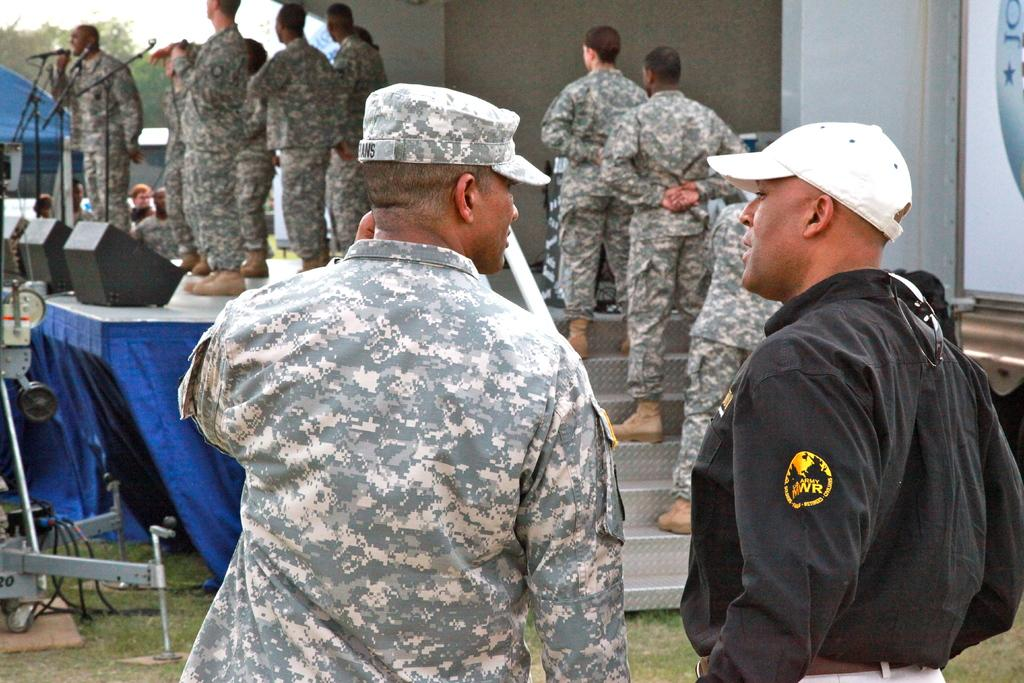What type of structures can be seen in the image? There are buildings in the image. What architectural feature is present in the image? There are stairs in the image. Can you describe the people in the image? There is a group of people in the image, and some of them are wearing army dresses. What is the purpose of the stage in the image? The stage in the image might be used for performances or speeches. Where are the microphones located in the image? The microphones are on the left side of the image. How many babies are present in the image? There are no babies present in the image. What type of wound can be seen on the stage in the image? There is no wound present in the image; it features a stage with microphones and a group of people, some of whom are wearing army dresses. 